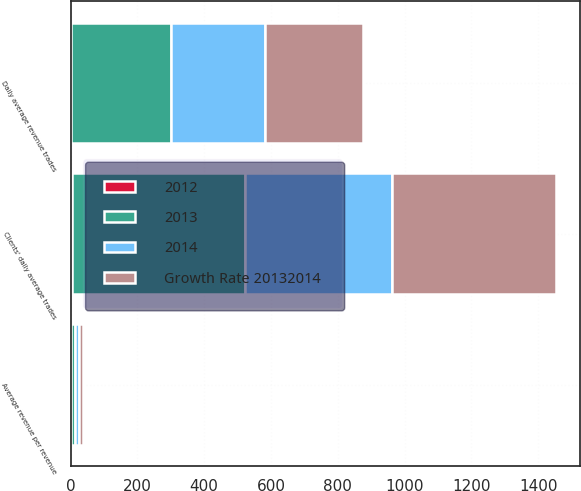<chart> <loc_0><loc_0><loc_500><loc_500><stacked_bar_chart><ecel><fcel>Daily average revenue trades<fcel>Clients' daily average trades<fcel>Average revenue per revenue<nl><fcel>2012<fcel>1<fcel>5<fcel>1<nl><fcel>2013<fcel>298.2<fcel>516.8<fcel>12.13<nl><fcel>Growth Rate 20132014<fcel>295<fcel>490.5<fcel>12.31<nl><fcel>2014<fcel>282.7<fcel>440.9<fcel>12.35<nl></chart> 